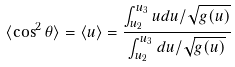Convert formula to latex. <formula><loc_0><loc_0><loc_500><loc_500>\langle \cos ^ { 2 } \theta \rangle = \langle u \rangle = \frac { \int _ { u _ { 2 } } ^ { u _ { 3 } } u d u / \sqrt { g ( u ) } } { \int _ { u _ { 2 } } ^ { u _ { 3 } } d u / \sqrt { g ( u ) } }</formula> 